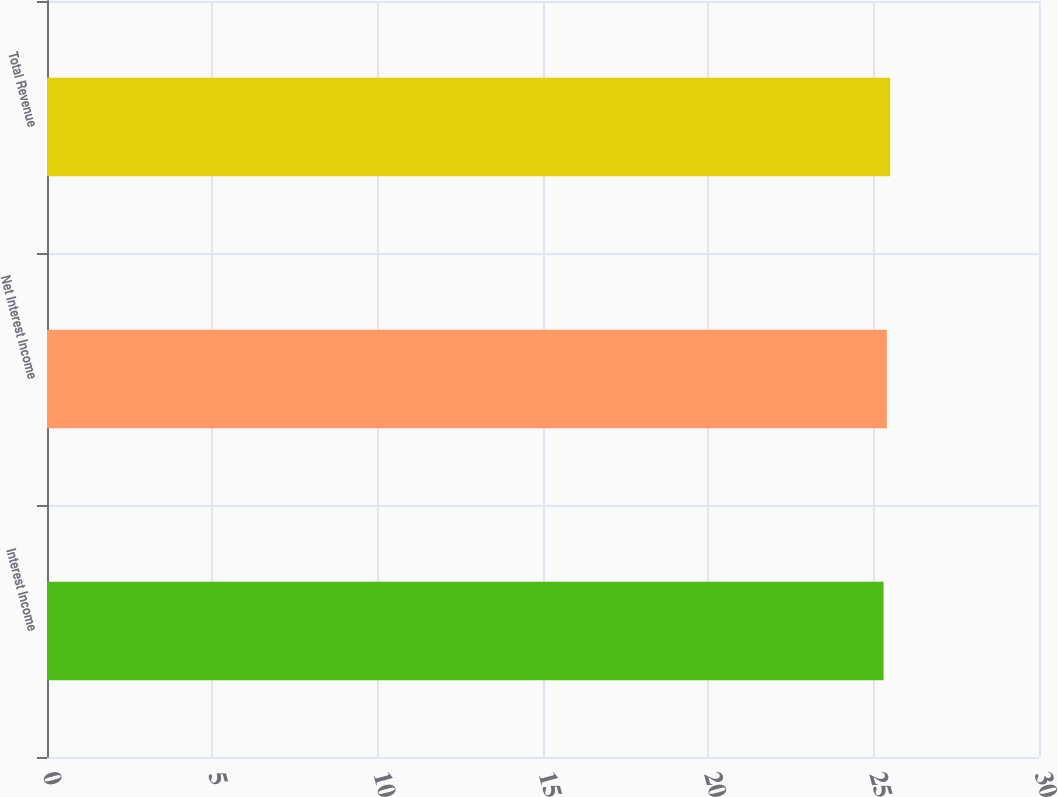Convert chart to OTSL. <chart><loc_0><loc_0><loc_500><loc_500><bar_chart><fcel>Interest Income<fcel>Net Interest Income<fcel>Total Revenue<nl><fcel>25.3<fcel>25.4<fcel>25.5<nl></chart> 